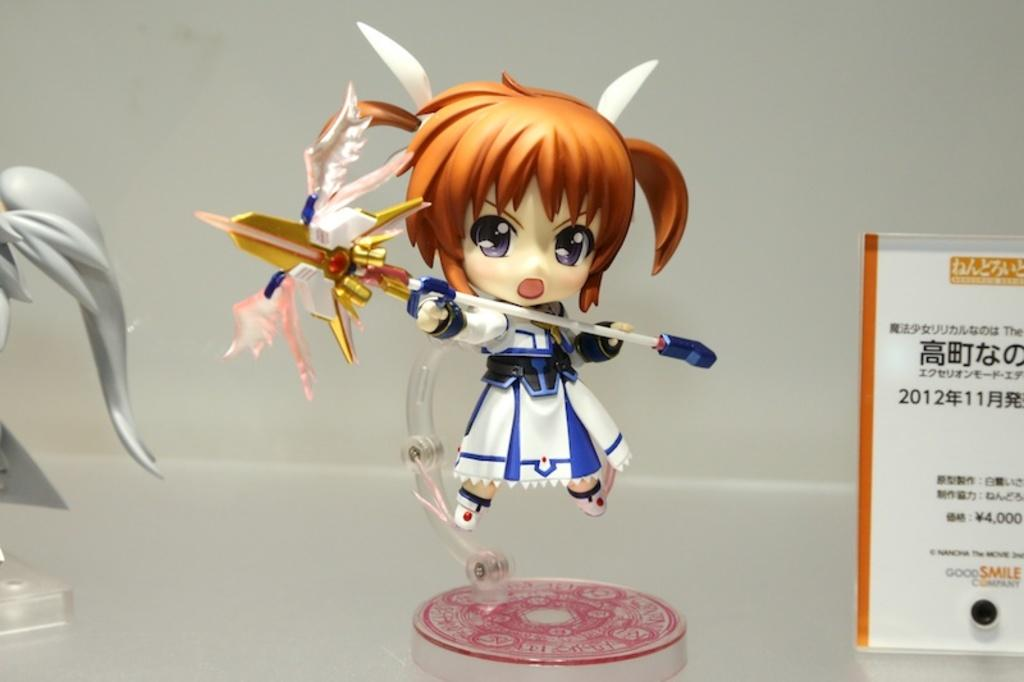What type of objects can be seen in the image? There are toys in the image. What is the board used for in the image? The purpose of the board in the image is not specified, but it could be a game board or a display board. What is the surface on which the objects are placed? There are objects on a surface in the image, but the specific material or type of surface is not mentioned. What can be seen in the background of the image? There is a wall visible in the background of the image. What type of wine is being served at the educational event in the image? There is no wine or educational event present in the image; it features toys and a board. How many potatoes are visible in the image? There are no potatoes present in the image. 